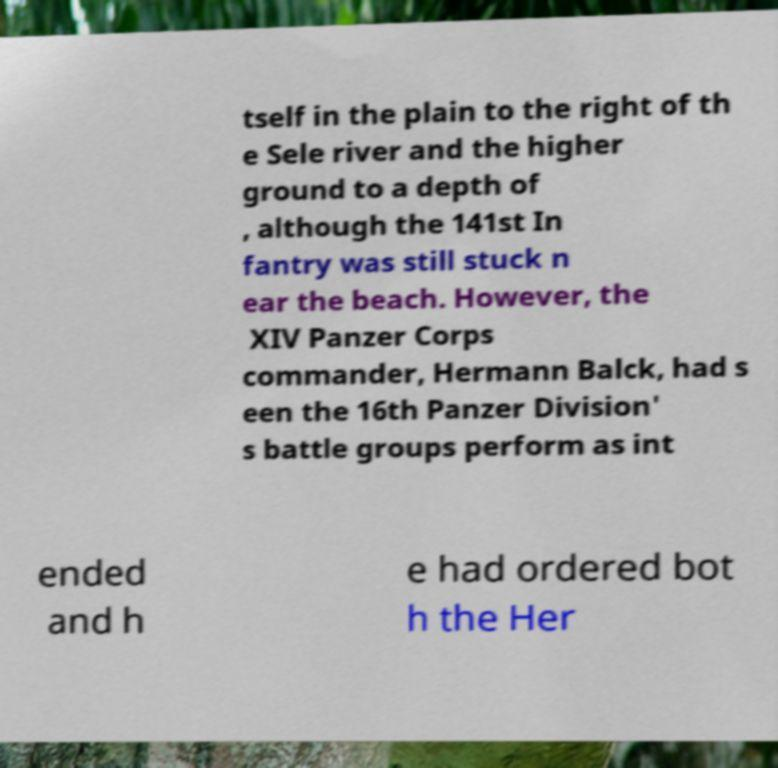Could you extract and type out the text from this image? tself in the plain to the right of th e Sele river and the higher ground to a depth of , although the 141st In fantry was still stuck n ear the beach. However, the XIV Panzer Corps commander, Hermann Balck, had s een the 16th Panzer Division' s battle groups perform as int ended and h e had ordered bot h the Her 